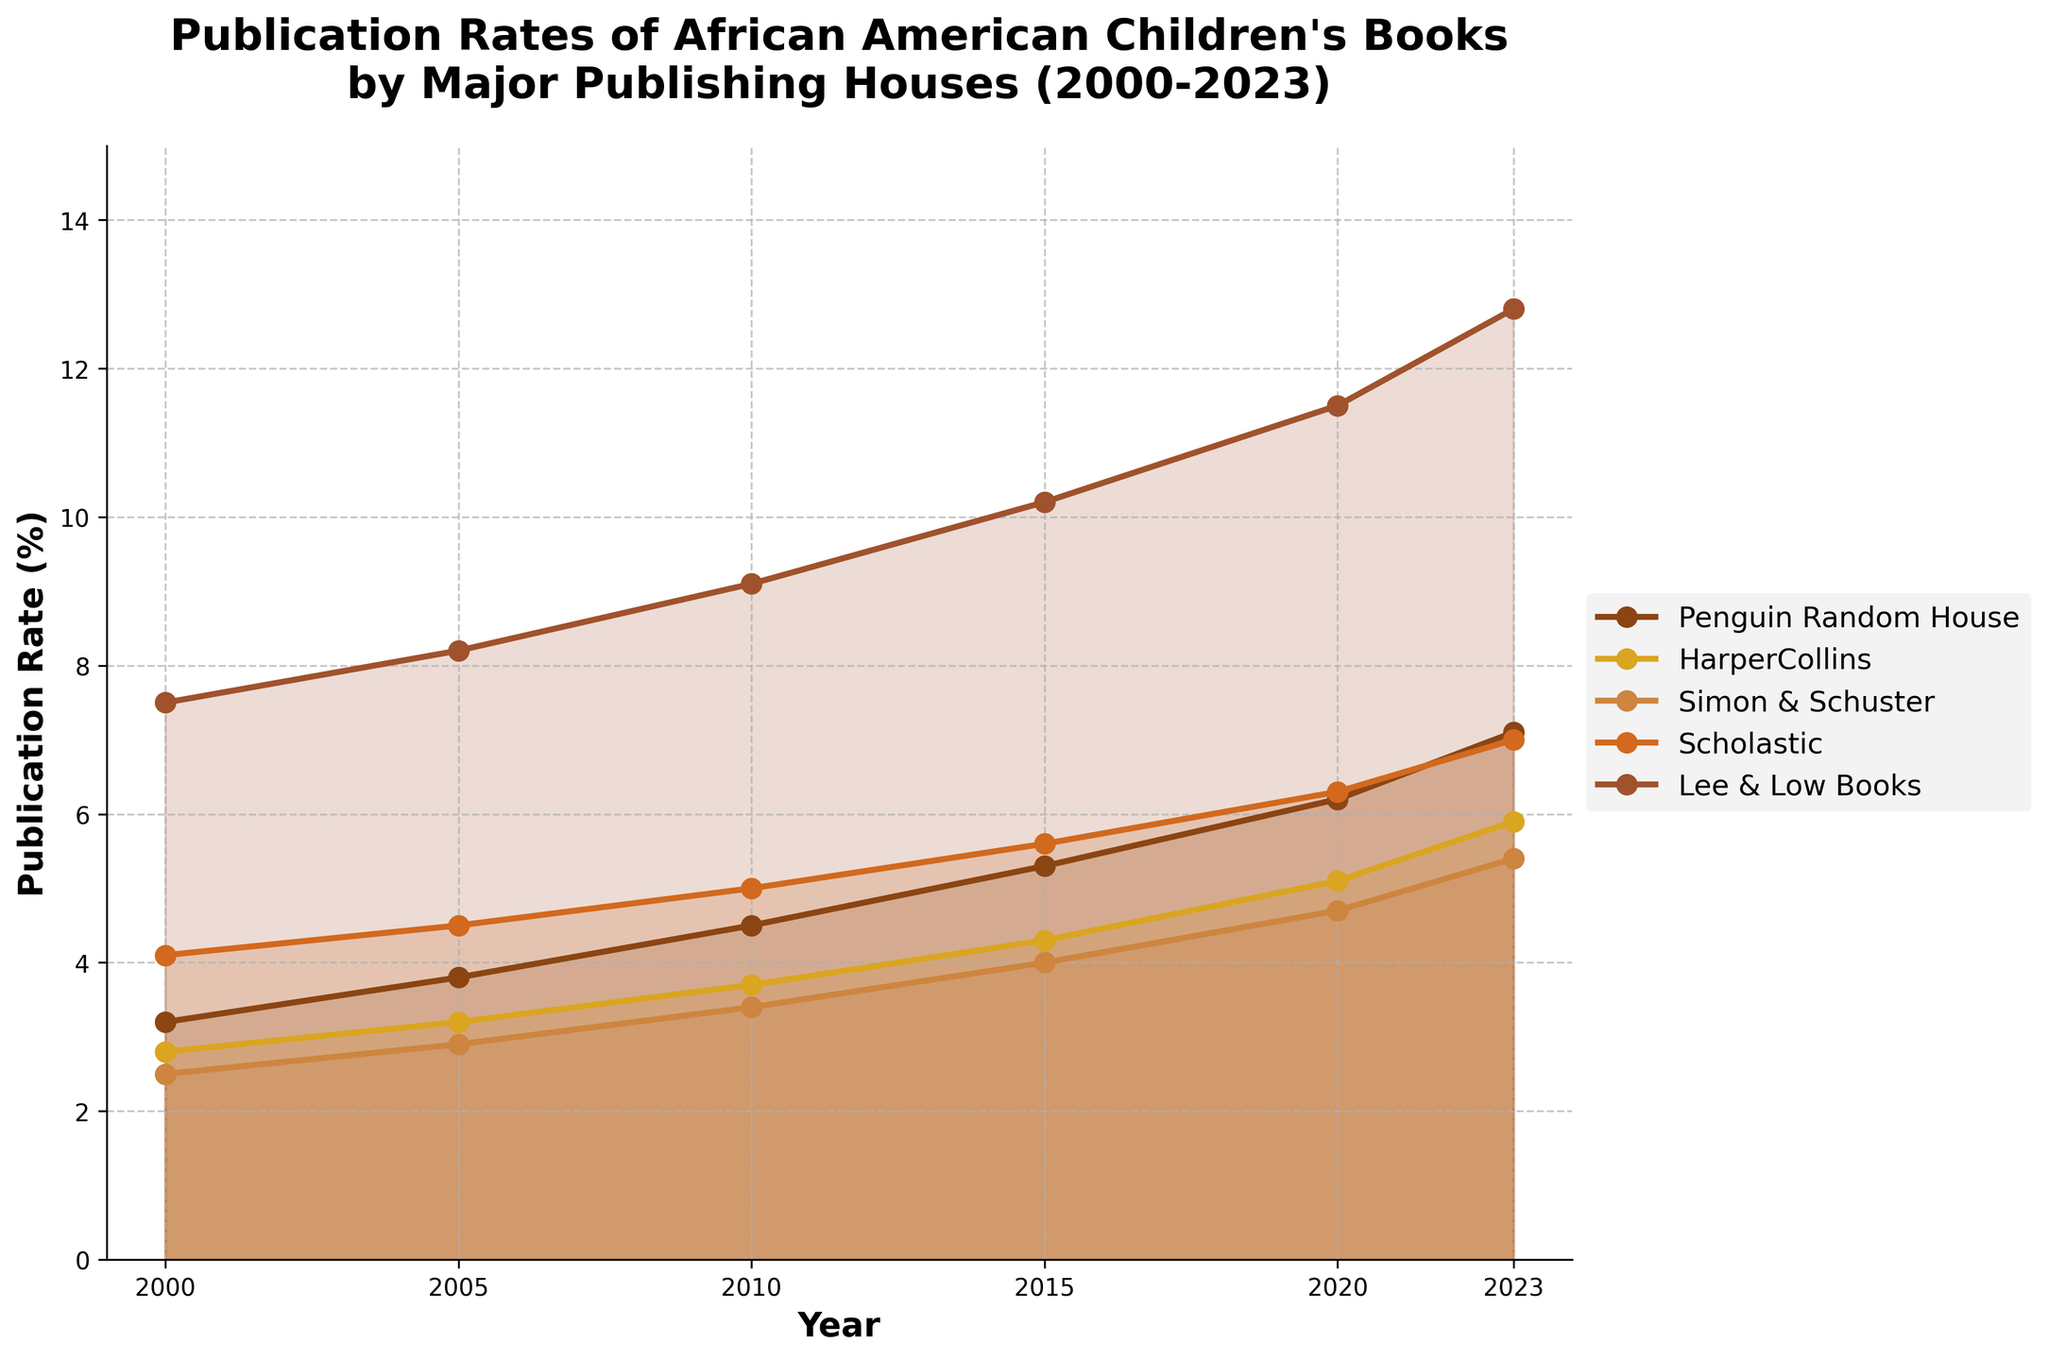What is the title of the figure? The title of the figure is located at the top. It provides an overall description of what the figure represents.
Answer: Publication Rates of African American Children's Books by Major Publishing Houses (2000-2023) Which publisher had the highest publication rate in 2023? Look at the values for the year 2023 on the x-axis and find the publisher with the highest value.
Answer: Lee & Low Books What is the range of publication rates for HarperCollins from 2000 to 2023? Identify the values of HarperCollins for the years 2000 and 2023, then calculate the range by subtracting the smallest value from the largest value.
Answer: 3.1 How did the publication rate for Penguin Random House change from 2000 to 2023? Compare the values for Penguin Random House between 2000 and 2023 and calculate the difference.
Answer: Increased by 3.9% Which publisher showed the most significant increase in publication rate between 2005 and 2010? Calculate the difference in publication rates between 2005 and 2010 for each publisher and identify the publisher with the largest increase.
Answer: Scholastic What is the average publication rate of Simon & Schuster over all the years shown? Sum the publication rates for Simon & Schuster from all the years and divide by the number of years (6).
Answer: 3.82% In which year did Scholastic and Simon & Schuster have an equal publication rate? Scan the figure to find the year where the lines for Scholastic and Simon & Schuster intersect.
Answer: No year Which publisher consistently had the lowest publication rate every year from 2000 to 2023? Check each year's data to determine which publisher had the lowest value every time.
Answer: Simon & Schuster What is the overall trend in publication rates for African American children's books? Observe the general direction of the lines for all publishers from 2000 to 2023.
Answer: Increasing trend Between 2000 and 2023, which publisher had the smallest total increase in publication rate? Calculate the difference between 2023 and 2000 rates for each publisher and identify the smallest increase.
Answer: Penguin Random House 